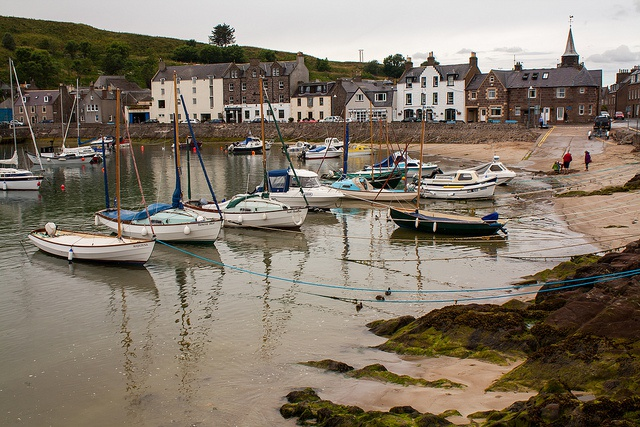Describe the objects in this image and their specific colors. I can see boat in lightgray, gray, black, and maroon tones, boat in lightgray, darkgray, gray, and black tones, boat in lightgray, darkgray, tan, and gray tones, boat in lightgray, gray, darkgray, and black tones, and boat in lightgray, black, tan, and gray tones in this image. 